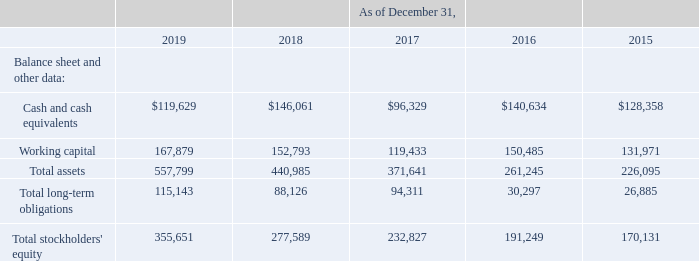ITEM 6. SELECTED FINANCIAL DATA
The selected consolidated statements of operations data for the years ended December 31, 2019, 2018 and 2017 and the selected consolidated balance sheet data as of December 31, 2019 and 2018 are derived from our audited consolidated financial statements included elsewhere in this Annual Report. The selected consolidated statements of operations data for the years ended December 31, 2016 and 2015 and the selected consolidated balance sheet data as of December 31, 2017, 2016 and 2015 are derived from our audited consolidated financial statements not included in this Annual Report. Our historical results are not necessarily indicative of the results to be expected in the future. The selected financial data should be read together with Item 7. "Management’s Discussion and Analysis of Financial Condition and Results of Operations" and in conjunction with our consolidated financial statements, related notes, and other financial information included elsewhere in this Annual Report. The following tables set forth our selected consolidated financial and other data for the years ended and as of December 31, 2019, 2018, 2017, 2016 and 2015 (in thousands, except share and per share data).
Information about prior period acquisitions that may affect the comparability of the selected financial information presented below is included in Item 1. Business. Information about the $28.0 million expense recorded in general and administrative expense in 2018, which relates to the agreement reached to settle the legal matter alleging violations of the Telephone Consumer Protection Act, or TCPA, and may affect the comparability of the selected financial information presented below, is disclosed in Item 3. “Legal Proceedings.” Information about the $1.7 million of interest recorded within interest income and the $6.9 million of gain recorded within other income, net, in 2019, which relates to promissory note proceeds received from one of our hardware suppliers and proceeds from an acquired promissory note, and may affect the comparability of the selected financial information presented below, is disclosed in Item 7. "Management’s Discussion and Analysis of Financial Condition and Results of Operations."
Certain previously reported amounts in the consolidated statements of operations for the years ended December 31, 2018, 2017, 2016 and 2015 have been reclassified to conform to our current presentation to reflect interest income as a separate line item, which was previously included in other income, net.
What were the cash and cash equivalents in 2019?
Answer scale should be: thousand. $119,629. What was the working capital in 2018?
Answer scale should be: thousand. 152,793. Which years does the table provide data for total assets? 2019, 2018, 2017, 2016, 2015. What was the change in working capital between 2015 and 2016?
Answer scale should be: thousand. 150,485-131,971
Answer: 18514. What was the change in total stockholders' equity between 2016 and 2017?
Answer scale should be: thousand. 232,827-191,249
Answer: 41578. What was the percentage change in the total assets between 2018 and 2019?
Answer scale should be: percent. (557,799-440,985)/440,985
Answer: 26.49. 